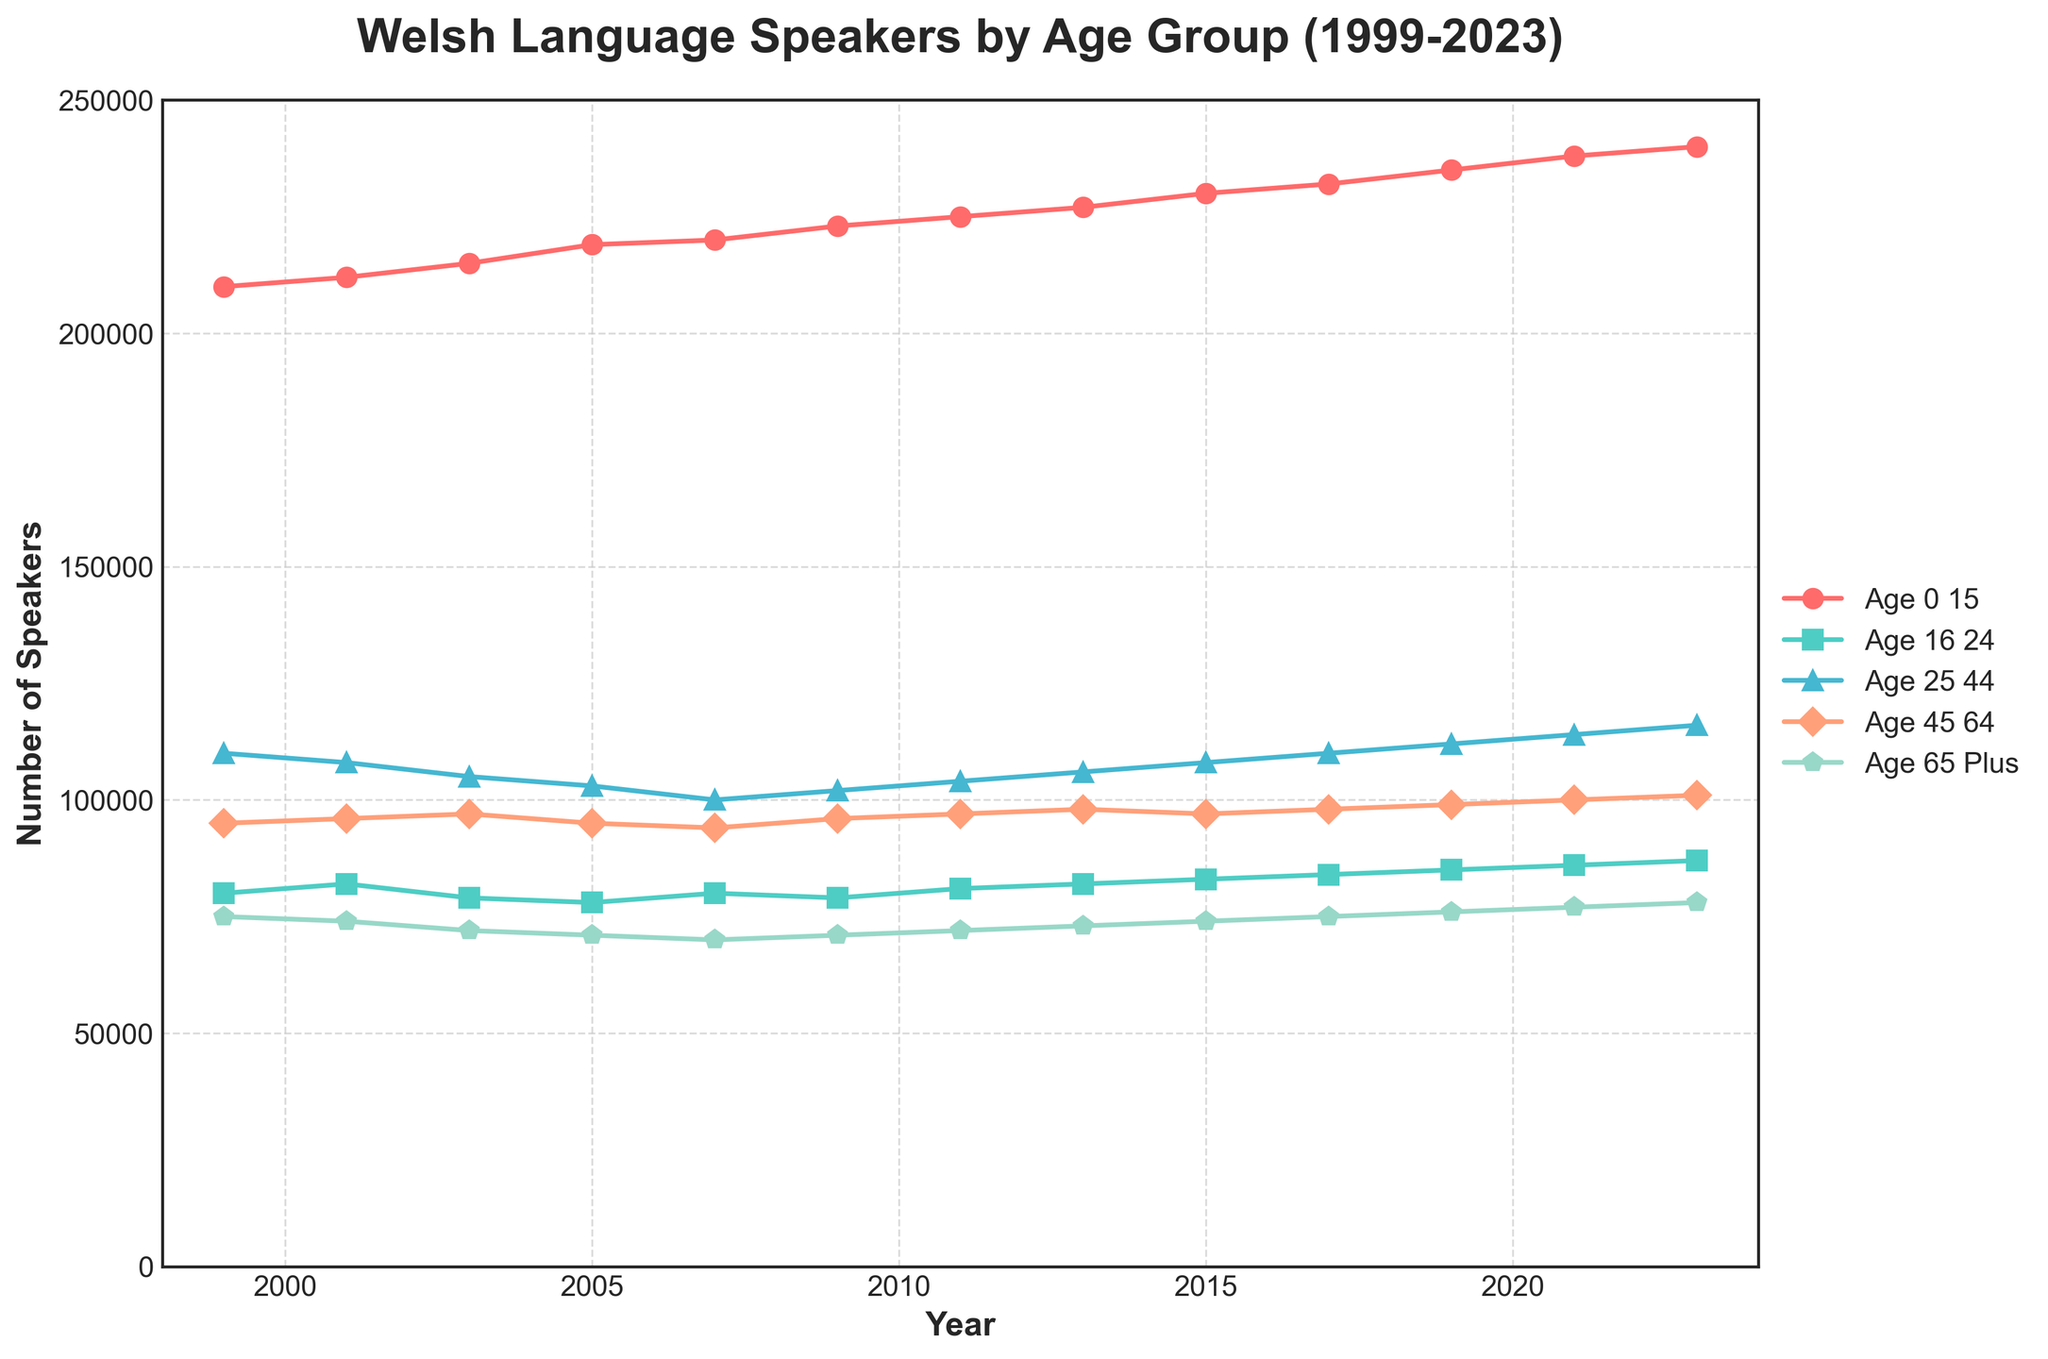what is the title of the plot? The title of the plot is located at the top, centering the viewer's attention. The text is "Welsh Language Speakers by Age Group (1999-2023)".
Answer: Welsh Language Speakers by Age Group (1999-2023) which age group has the highest number of speakers in 2023? By following the year 2023 on the x-axis vertically, the highest y-value point is marked for the 'Age 0-15' group in red.
Answer: Age 0-15 which age group shows the most significant increase in speakers from 1999 to 2023? Calculate the difference between the 2023 and 1999 values for each age group and compare. Age 0-15 increases from 210,000 to 240,000 (30,000 increase). Age 16-24 increases by 7,000, Age 25-44 by 6,000, Age 45-64 by 6,000, and Age 65 Plus by 3,000. The Age 0-15 group has the largest increase.
Answer: Age 0-15 how many total speakers are there across all age groups in 2005? Add the numbers of all age groups for the year 2005. 219,000 (Age 0-15) + 78,000 (Age 16-24) + 103,000 (Age 25-44) + 95,000 (Age 45-64) + 71,000 (Age 65 Plus) = 566,000.
Answer: 566,000 which two age groups have the closest number of speakers in 2017? Compare the values of all groups in 2017. Age groups 25-44 with 110,000 and 45-64 with 98,000 are closest with a difference of 12,000.
Answer: Age 25-44 and Age 45-64 how did the number of speakers aged 65 plus change from 2001 to 2009? Check the values for 2001 (74,000) and 2009 (71,000), and find the difference. 71,000 - 74,000 = -3,000, indicating a decrease of 3,000 speakers.
Answer: Decreased by 3,000 among which two years did the Age 0-15 group see the highest increase in the number of speakers? Compare year-to-year changes for Age 0-15. The highest single-year increase is between 2019 and 2021, going from 235,000 to 238,000, a 3,000 increase.
Answer: 2019 to 2021 how does the trend in the number of speakers for Age 16-24 compare to Age 25-44? Both groups have relatively stable, slightly increasing trends over the years. The Age 16-24 group starts with a dip around 2003 before stabilizing, while the Age 25-44 group shows more consistency. Both end with moderate increases by 2023.
Answer: Similar steady increase what is the average number of speakers for Age 45-64 from 1999 to 2023? Sum their values: 95,000 + 96,000 + 97,000 + 95,000 + 94,000 + 96,000 + 97,000 + 98,000 + 97,000 + 98,000 + 99,000 + 100,000 + 101,000; total is 1,158,000. Divide by 13 (number of years) to get the average: 1,158,000 / 13 ≈ 89,077
Answer: 89,077 